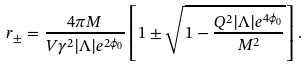<formula> <loc_0><loc_0><loc_500><loc_500>r _ { \pm } = \frac { 4 \pi M } { V \gamma ^ { 2 } | \Lambda | e ^ { 2 \phi _ { 0 } } } \left [ 1 \pm \sqrt { 1 - \frac { Q ^ { 2 } | \Lambda | e ^ { 4 \phi _ { 0 } } } { M ^ { 2 } } } \right ] .</formula> 